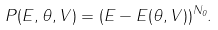Convert formula to latex. <formula><loc_0><loc_0><loc_500><loc_500>P ( E , \theta , V ) = ( E - E ( \theta , V ) ) ^ { N _ { 0 } } .</formula> 